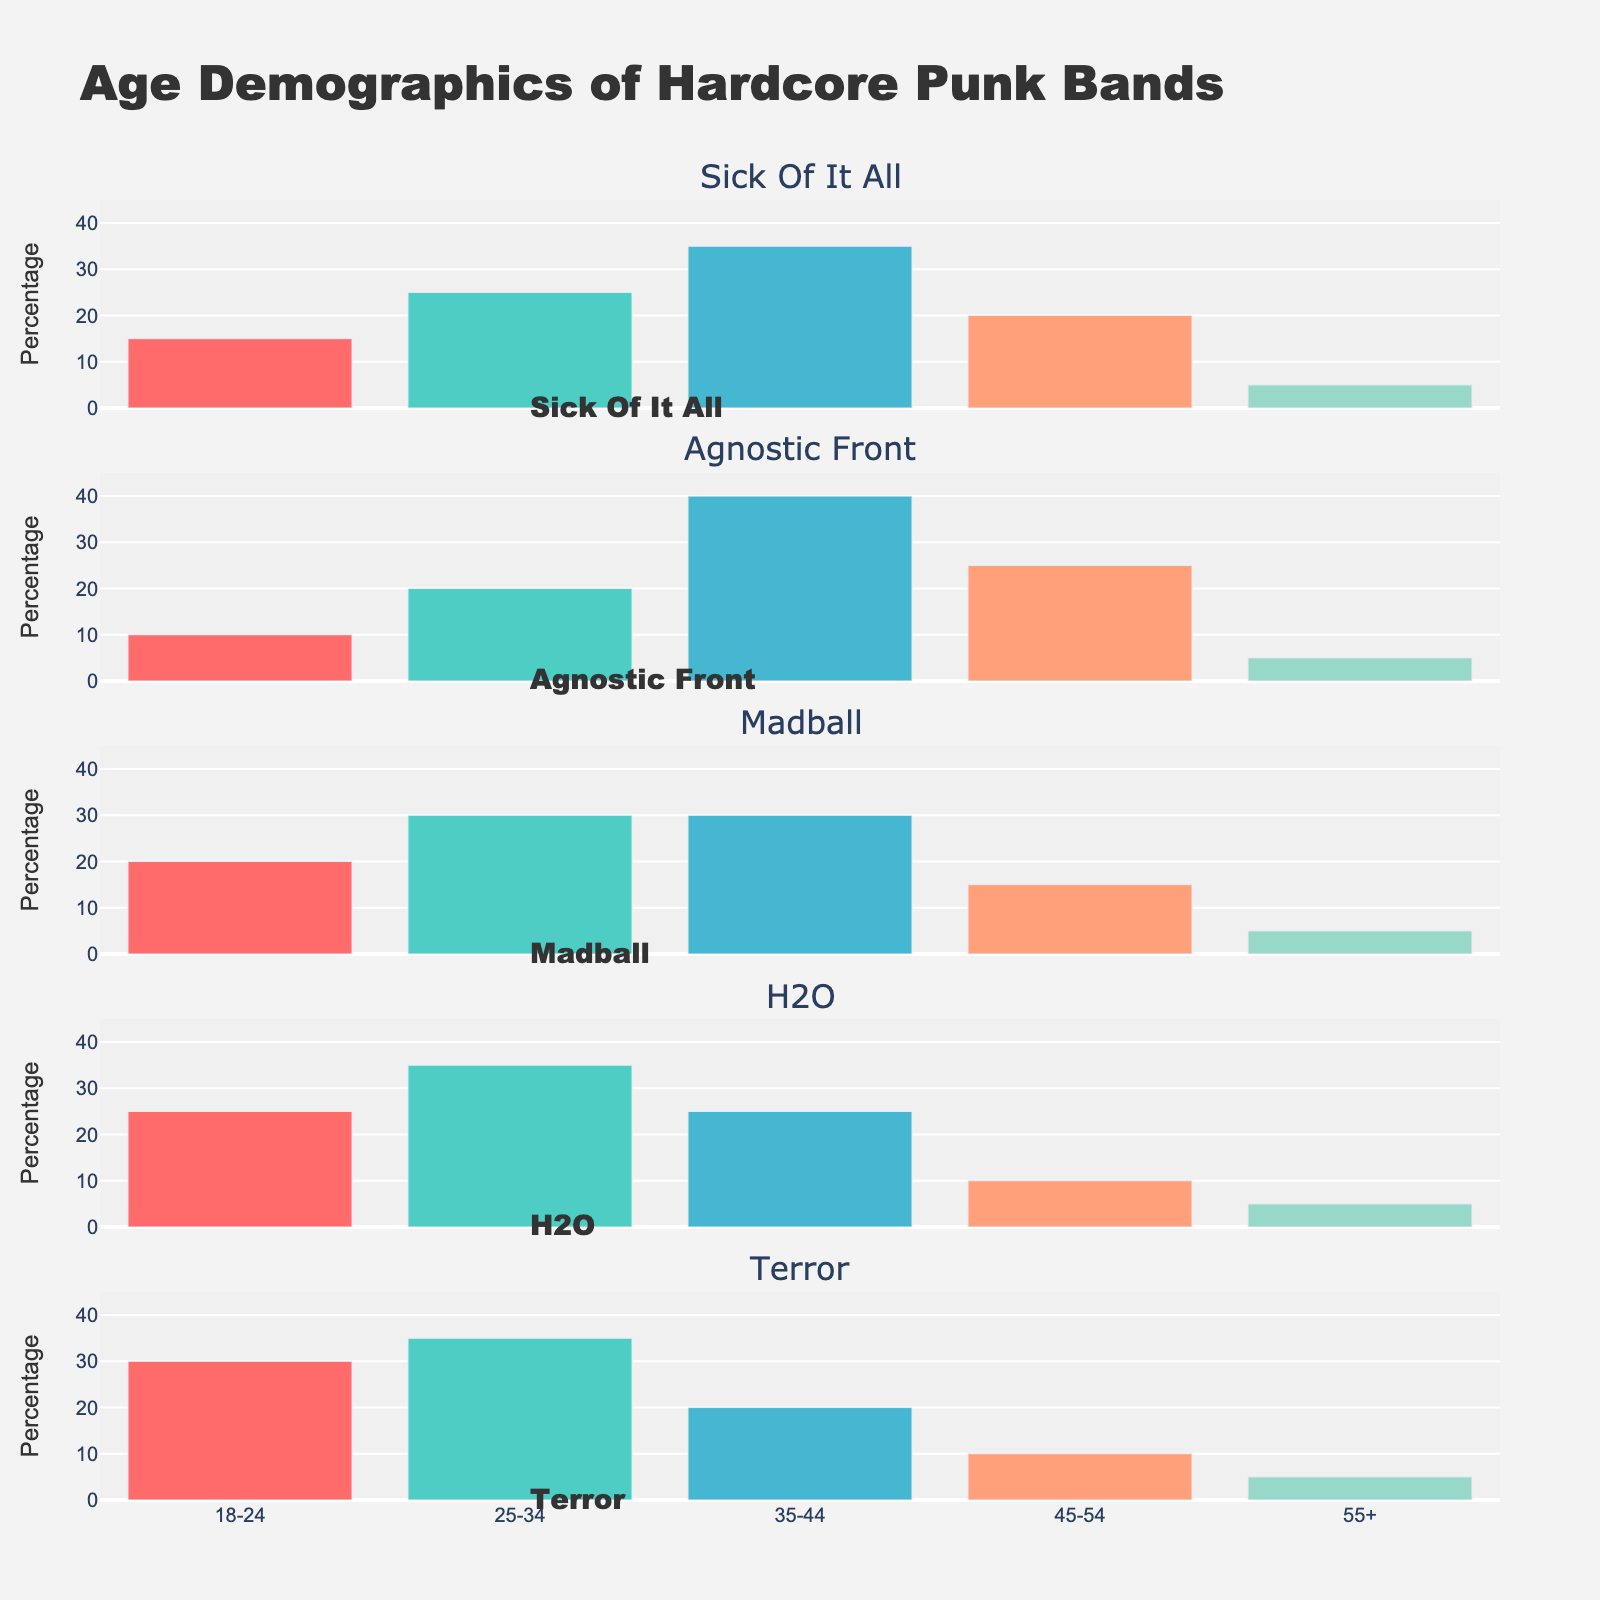What is the title of the figure? The title of the figure is displayed at the top and it indicates the main topic being visualized. The title reads "Age Demographics of Hardcore Punk Bands".
Answer: Age Demographics of Hardcore Punk Bands What age group has the highest percentage of fans for the band Sick Of It All? By looking at the bar corresponding to the band Sick Of It All, you can observe which age group has the tallest bar. The tallest bar indicates the age group with the highest percentage of fans. For Sick Of It All, the 35-44 age group has the highest percentage of fans.
Answer: 35-44 Which band has the largest percentage of fans aged 18-24? Check each band’s subplot by examining the height of the bar in the 18-24 category. The tallest bar in the 18-24 category across all bands indicates the largest percentage. The band Terror has the largest percentage in this age group.
Answer: Terror How many bands have exactly 5% of their fans in the 55+ age group? Count the number of bands where the height of the bar in the 55+ age category is equal to the value 5%. In the figure, all five bands Sick Of It All, Agnostic Front, Madball, H2O, and Terror have 5% of their fans in the 55+ age group.
Answer: 5 What is the combined percentage of fans aged 25-34 and 35-44 for Madball? For the band Madball, add the percentage values of the fans aged 25-34 and 35-44. The figure shows 30% for 25-34 and 30% for 35-44. The sum is 30 + 30 = 60.
Answer: 60% Which band has the highest variation in fan percentages across age groups? To determine this, identify the band with the largest range between their highest and lowest bars across all age categories. For Agnostic Front, the difference between the highest (40% for 35-44) and lowest (5% for 55+) fan group is 35%. This is the highest variation among the bands.
Answer: Agnostic Front How does the percentage of fans aged 45-54 for Sick Of It All compare to H2O? Look at the heights of the bars in the 45-54 category for Sick Of It All and H2O. Sick Of It All has 20% of fans aged 45-54, while H2O has 10%. Sick Of It All has a higher percentage in this age group by 10%.
Answer: Sick Of It All has 10% more What is the average percentage of fans aged 35-44 across all bands? Add the percentages of fans aged 35-44 for all bands, then divide by the number of bands. The data shows 35% for Sick Of It All, 40% for Agnostic Front, 30% for Madball, 25% for H2O, and 20% for Terror. The total is 35 + 40 + 30 + 25 + 20 = 150. The average is 150 / 5 = 30.
Answer: 30% What age group consistently has the smallest percentage of fans across all bands? Check the smallest bar in each band’s subplot. The 55+ age group has consistently the smallest percentage (5%) across all five bands.
Answer: 55+ 